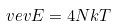<formula> <loc_0><loc_0><loc_500><loc_500>\ v e v { E } = 4 N k T</formula> 